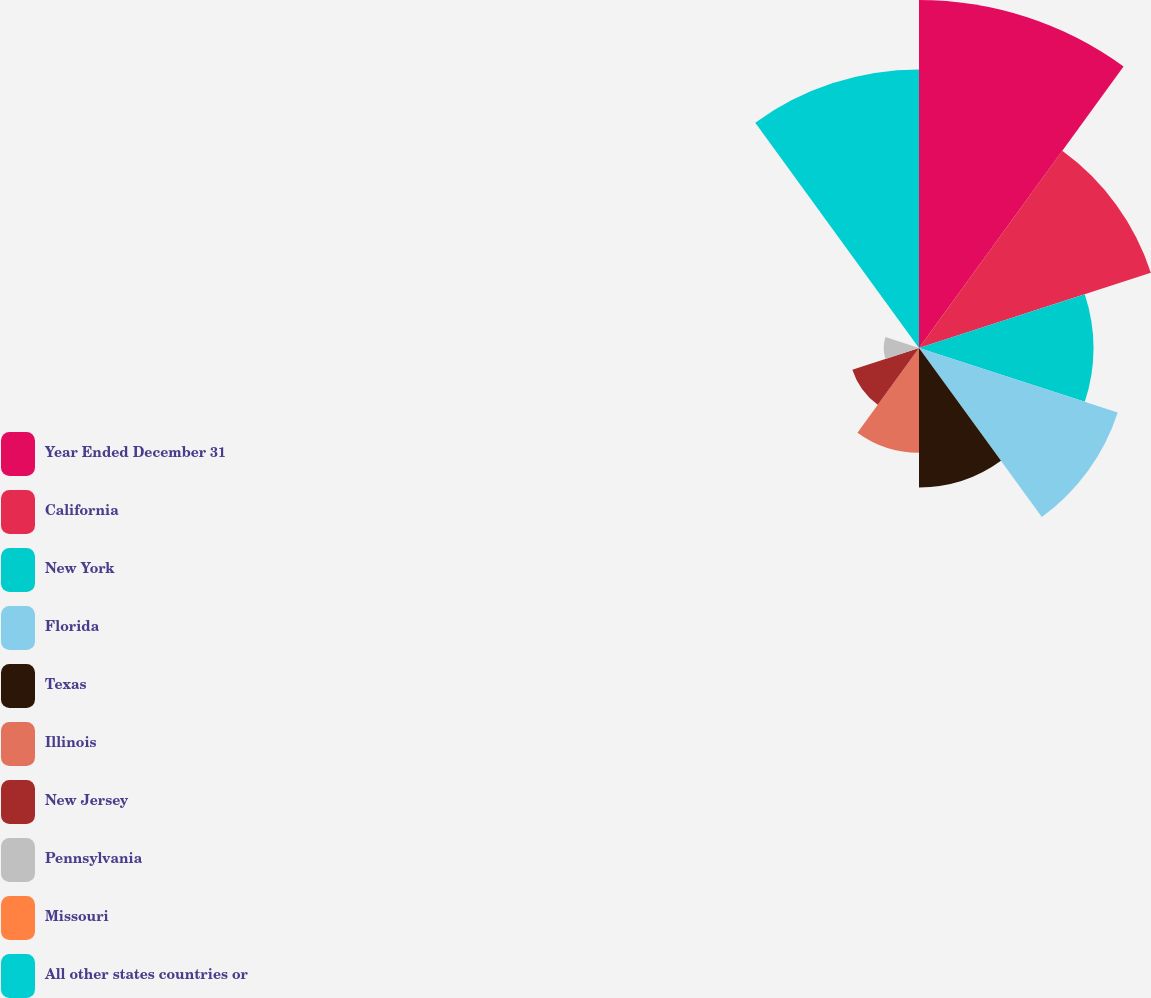Convert chart. <chart><loc_0><loc_0><loc_500><loc_500><pie_chart><fcel>Year Ended December 31<fcel>California<fcel>New York<fcel>Florida<fcel>Texas<fcel>Illinois<fcel>New Jersey<fcel>Pennsylvania<fcel>Missouri<fcel>All other states countries or<nl><fcel>21.7%<fcel>15.2%<fcel>10.87%<fcel>13.03%<fcel>8.7%<fcel>6.53%<fcel>4.37%<fcel>2.2%<fcel>0.03%<fcel>17.37%<nl></chart> 